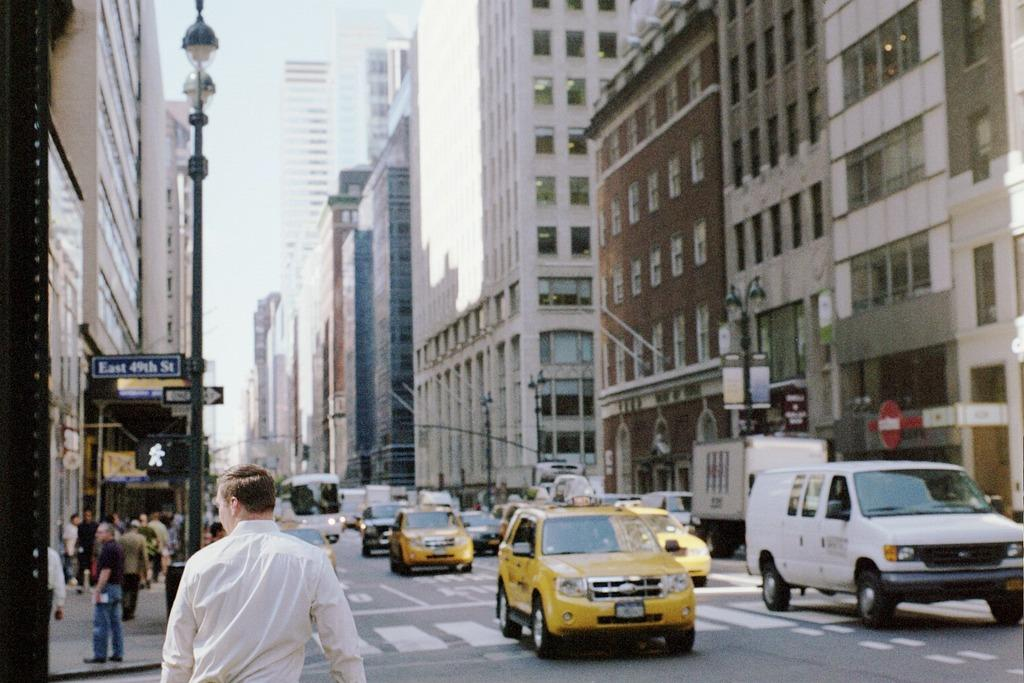<image>
Render a clear and concise summary of the photo. Traffic passes by the corner of East 49th Street. 